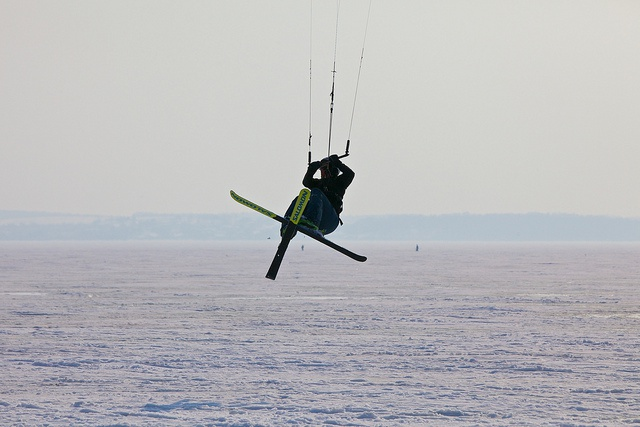Describe the objects in this image and their specific colors. I can see people in lightgray, black, darkblue, and gray tones and skis in lightgray, black, olive, navy, and gray tones in this image. 